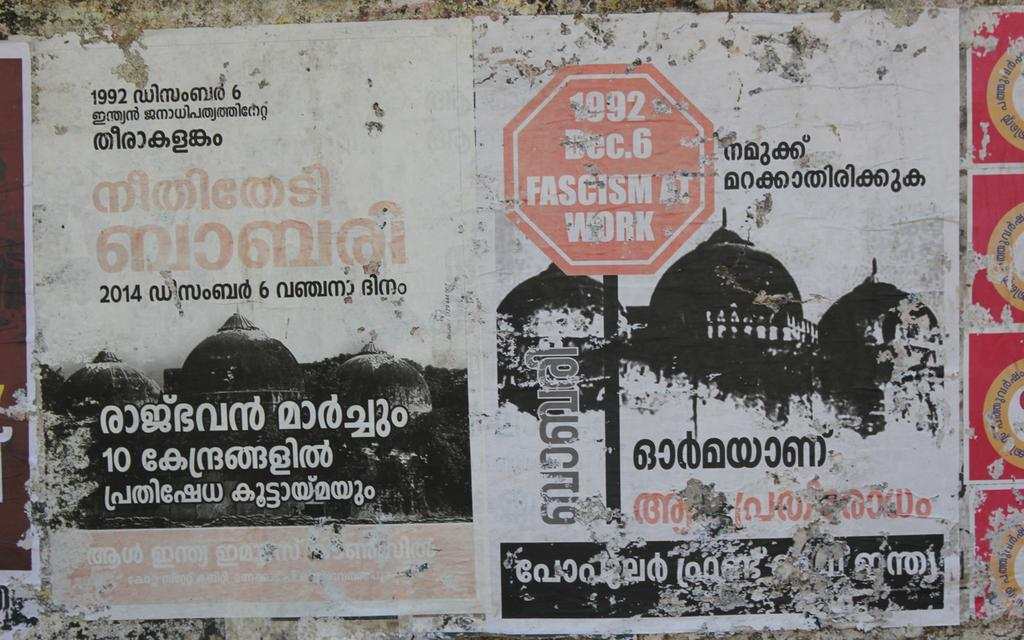<image>
Offer a succinct explanation of the picture presented. Two worn posters, dated 1992, are side by side on a wall. 